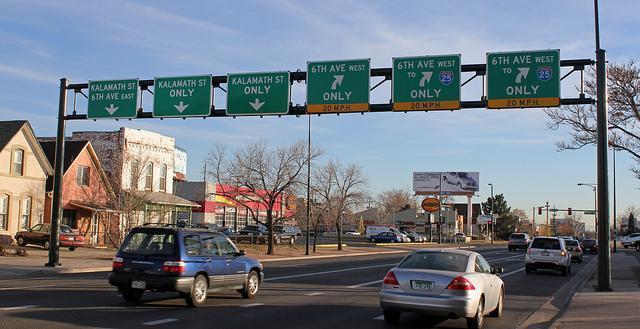How many cars are there?
Give a very brief answer. 2. 